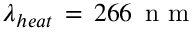Convert formula to latex. <formula><loc_0><loc_0><loc_500><loc_500>\lambda _ { h e a t } \, = \, 2 6 6 \, n m</formula> 